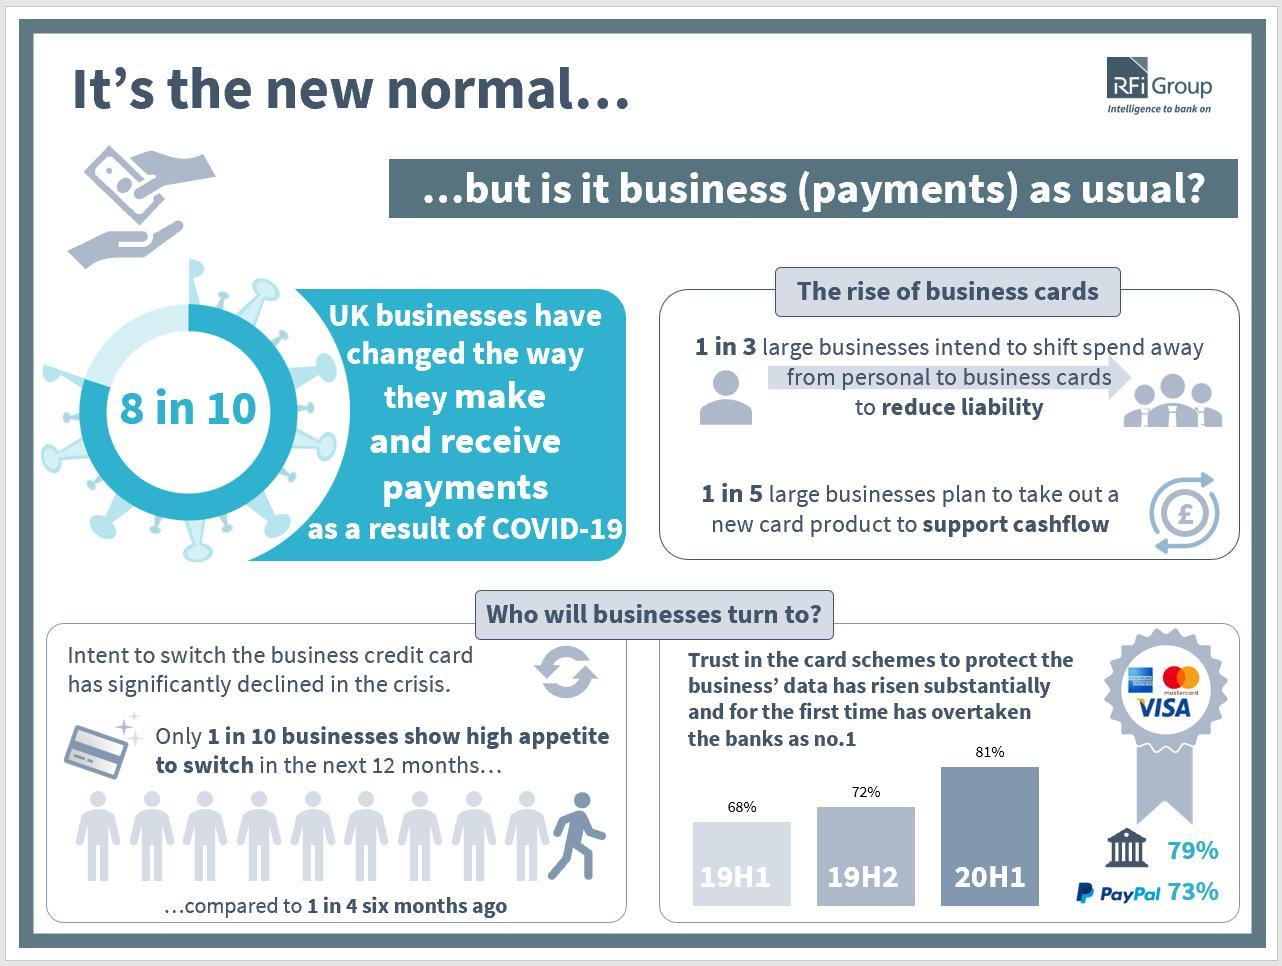What 'percentage' of UK businesses have changed the way they make and receive payments?
Answer the question with a short phrase. 80% Which are the three credit cards shown in the image? American express, MasterCard, Visa What 'percentage' of businesses intent to switch credit card in the next 12 months? 10% 